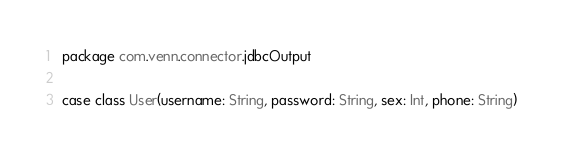Convert code to text. <code><loc_0><loc_0><loc_500><loc_500><_Scala_>package com.venn.connector.jdbcOutput

case class User(username: String, password: String, sex: Int, phone: String)</code> 